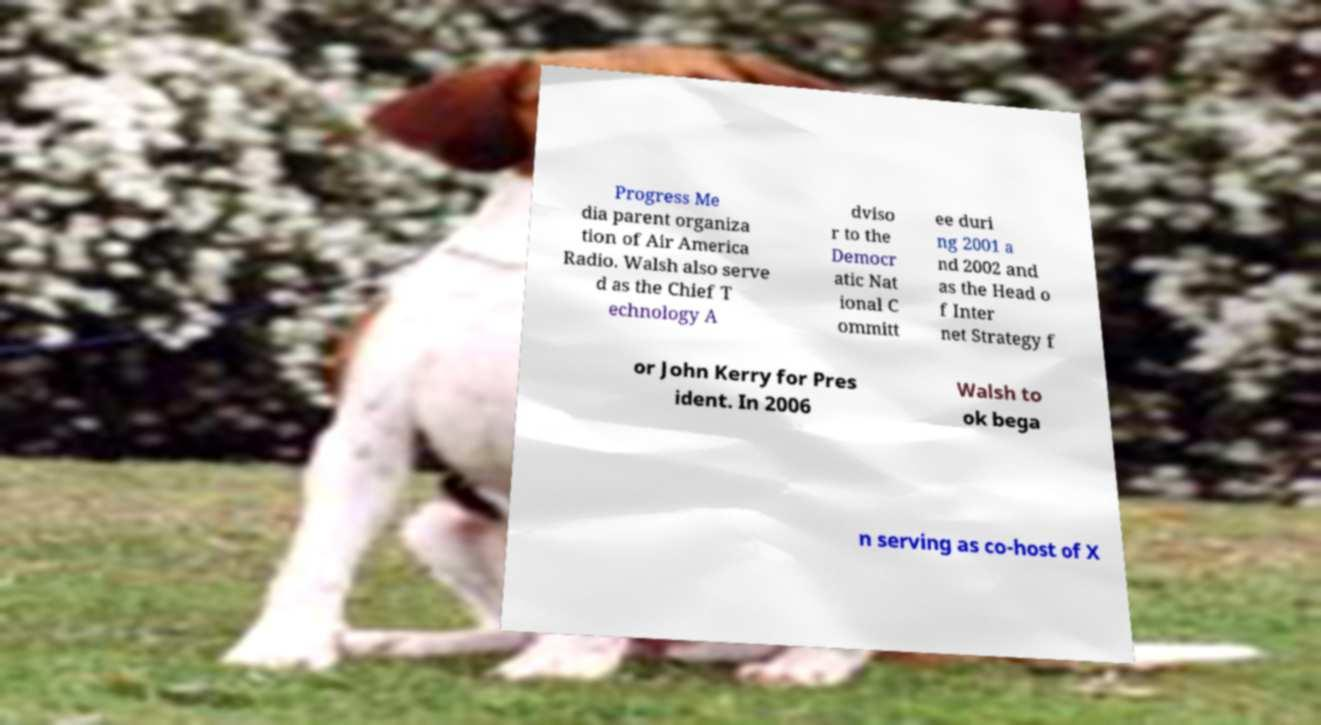Can you read and provide the text displayed in the image?This photo seems to have some interesting text. Can you extract and type it out for me? Progress Me dia parent organiza tion of Air America Radio. Walsh also serve d as the Chief T echnology A dviso r to the Democr atic Nat ional C ommitt ee duri ng 2001 a nd 2002 and as the Head o f Inter net Strategy f or John Kerry for Pres ident. In 2006 Walsh to ok bega n serving as co-host of X 